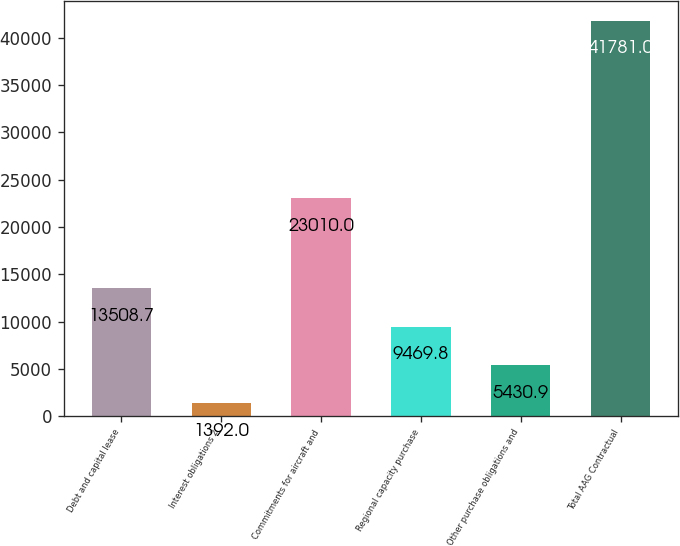Convert chart. <chart><loc_0><loc_0><loc_500><loc_500><bar_chart><fcel>Debt and capital lease<fcel>Interest obligations 2<fcel>Commitments for aircraft and<fcel>Regional capacity purchase<fcel>Other purchase obligations and<fcel>Total AAG Contractual<nl><fcel>13508.7<fcel>1392<fcel>23010<fcel>9469.8<fcel>5430.9<fcel>41781<nl></chart> 